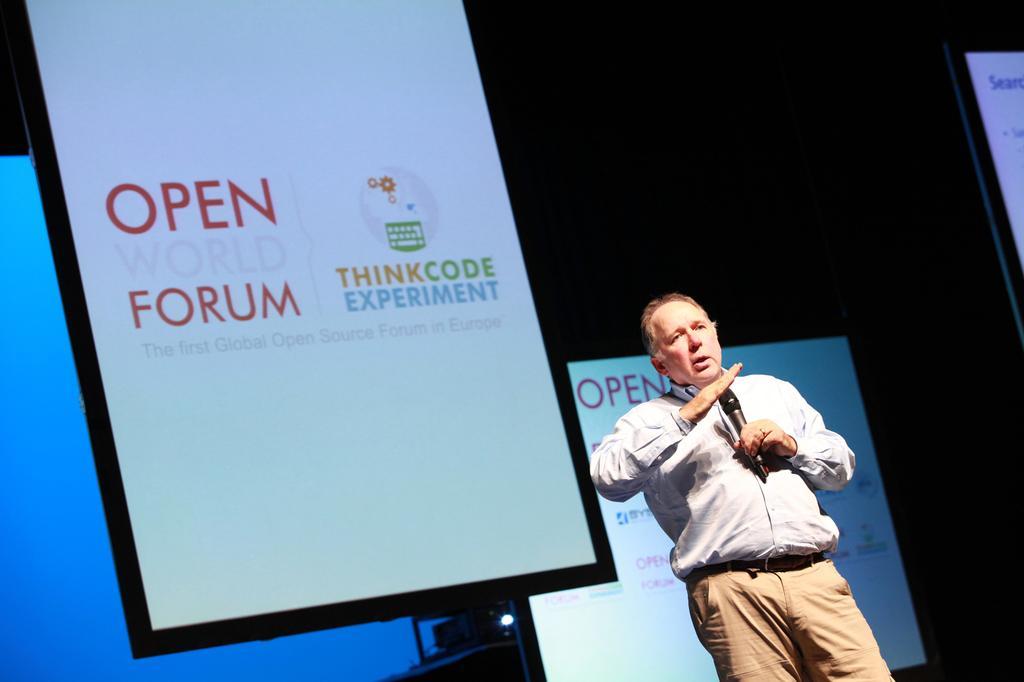In one or two sentences, can you explain what this image depicts? In this image there is a person standing and talking, there is a person holding microphone, there are screens, there is text on the screen, there is a projector on the surface, there is a screen truncated towards the left of the image. 